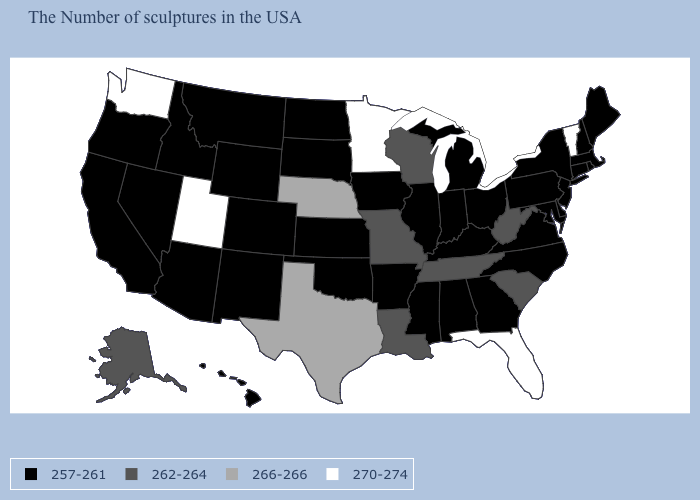What is the value of Kansas?
Quick response, please. 257-261. Among the states that border Ohio , which have the highest value?
Short answer required. West Virginia. What is the value of Connecticut?
Give a very brief answer. 257-261. Name the states that have a value in the range 266-266?
Quick response, please. Nebraska, Texas. What is the value of Connecticut?
Be succinct. 257-261. Name the states that have a value in the range 262-264?
Answer briefly. South Carolina, West Virginia, Tennessee, Wisconsin, Louisiana, Missouri, Alaska. Name the states that have a value in the range 266-266?
Short answer required. Nebraska, Texas. Does Colorado have the same value as Minnesota?
Answer briefly. No. Does Pennsylvania have a lower value than Missouri?
Give a very brief answer. Yes. Does the map have missing data?
Short answer required. No. Does Louisiana have the lowest value in the USA?
Write a very short answer. No. How many symbols are there in the legend?
Be succinct. 4. Which states hav the highest value in the Northeast?
Quick response, please. Vermont. What is the highest value in the USA?
Be succinct. 270-274. 